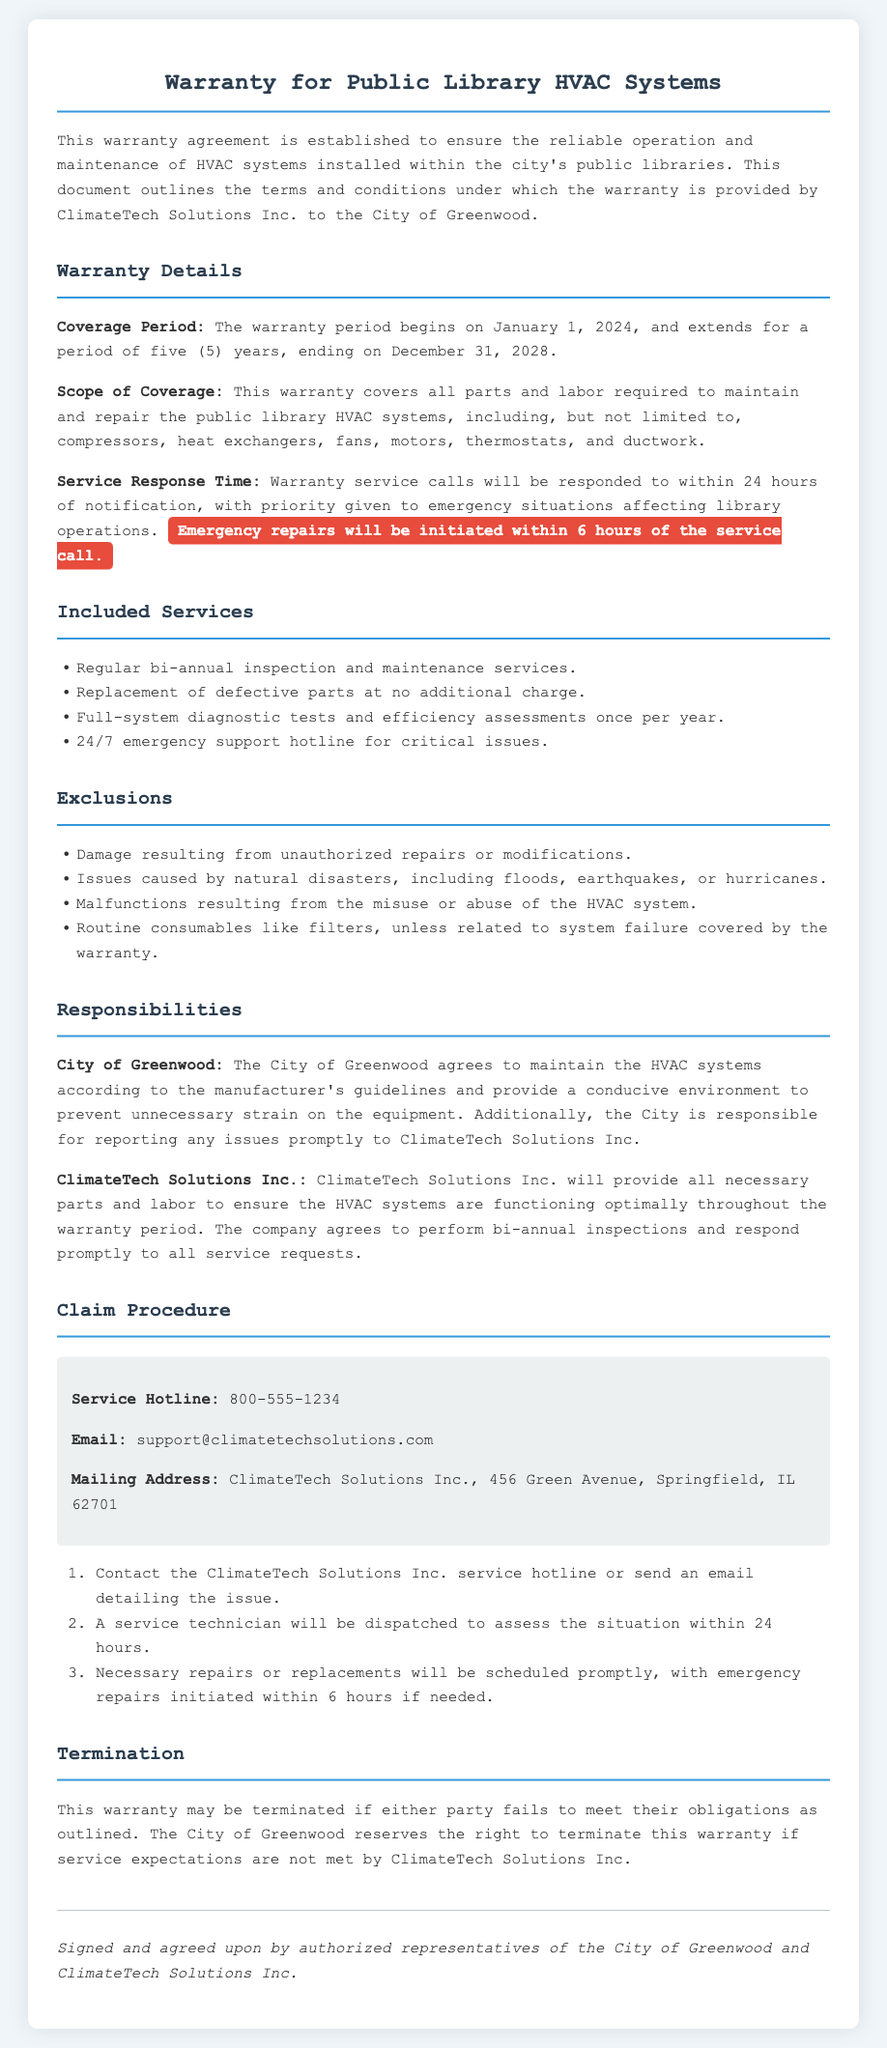What is the coverage period of the warranty? The warranty period begins on January 1, 2024, and extends for a period of five years, ending on December 31, 2028.
Answer: January 1, 2024, to December 31, 2028 Who provides the warranty? The document states that the warranty is provided by ClimateTech Solutions Inc.
Answer: ClimateTech Solutions Inc What types of inspections are included? The document specifies that regular bi-annual inspection and maintenance services are included.
Answer: Bi-annual inspection and maintenance services What is the emergency repair response time? The document states that emergency repairs will be initiated within 6 hours of the service call.
Answer: 6 hours What is excluded from the warranty coverage? The document lists several exclusions, including damage from unauthorized repairs and natural disasters.
Answer: Damage from unauthorized repairs or natural disasters What is the service hotline number? The document provides a specific contact for service issues, which is a hotline number.
Answer: 800-555-1234 What happens if either party fails to meet their obligations? The document outlines that the warranty may be terminated if obligations are not met.
Answer: Terminated What is the frequency of full-system diagnostic tests? The document mentions that full-system diagnostic tests and efficiency assessments are performed once per year.
Answer: Once per year 